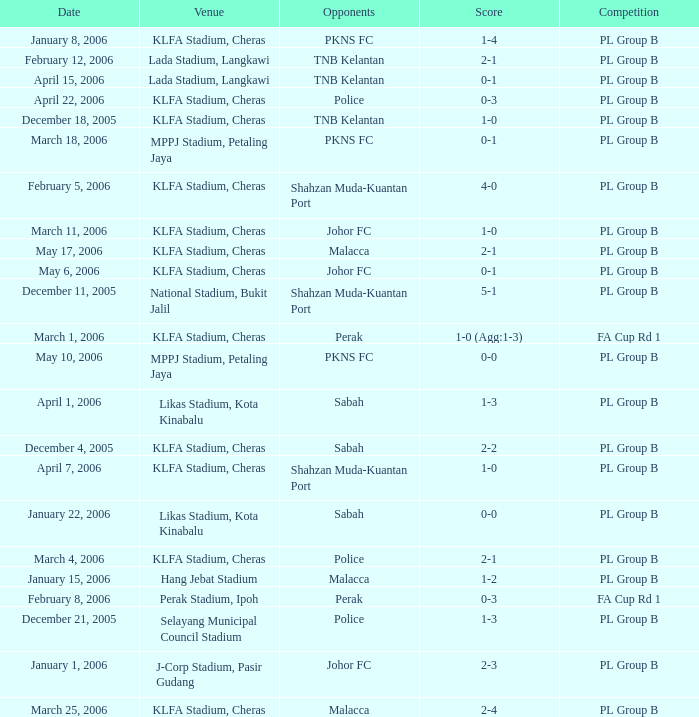Which Score has Opponents of pkns fc, and a Date of january 8, 2006? 1-4. 